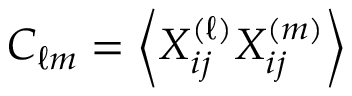Convert formula to latex. <formula><loc_0><loc_0><loc_500><loc_500>C _ { \ell m } = \left \langle X _ { i j } ^ { ( \ell ) } X _ { i j } ^ { ( m ) } \right \rangle</formula> 